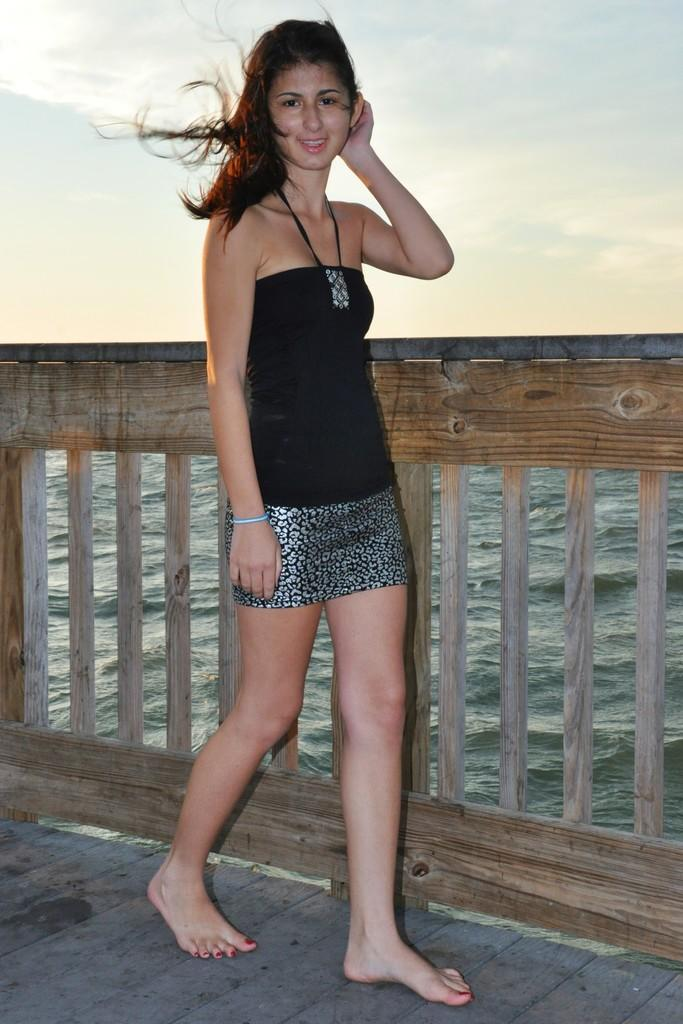Who is present in the image? There is a woman in the image. What is the woman's position in the image? The woman is on the ground. What can be seen in the background of the image? There is a fence, water, and the sky visible in the background of the image. What type of drink is the woman holding in the image? There is no drink visible in the image; the woman is not holding anything. 